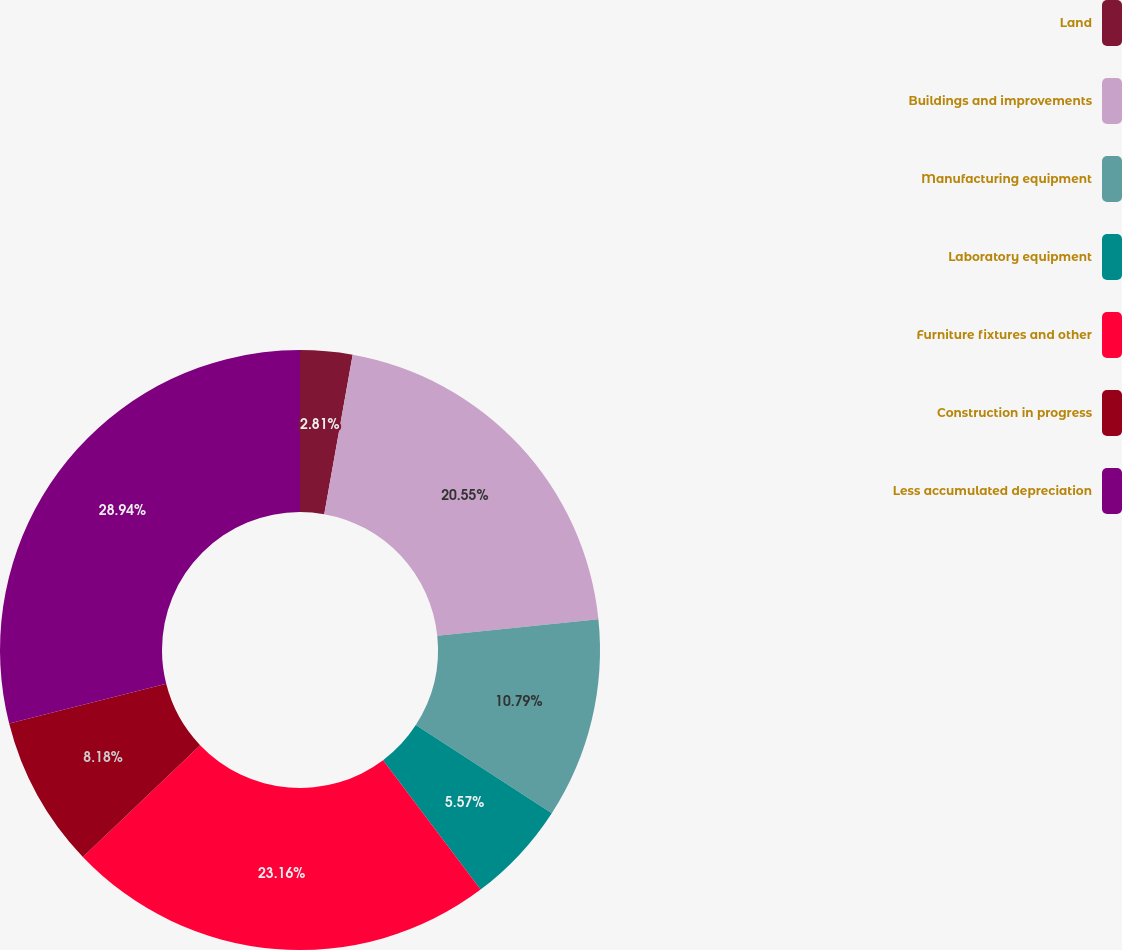Convert chart. <chart><loc_0><loc_0><loc_500><loc_500><pie_chart><fcel>Land<fcel>Buildings and improvements<fcel>Manufacturing equipment<fcel>Laboratory equipment<fcel>Furniture fixtures and other<fcel>Construction in progress<fcel>Less accumulated depreciation<nl><fcel>2.81%<fcel>20.55%<fcel>10.79%<fcel>5.57%<fcel>23.16%<fcel>8.18%<fcel>28.94%<nl></chart> 